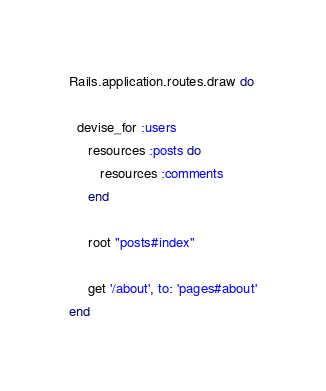Convert code to text. <code><loc_0><loc_0><loc_500><loc_500><_Ruby_>Rails.application.routes.draw do
	 
  devise_for :users
	 resources :posts do 
	 	resources :comments
	 end

	 root "posts#index"

	 get '/about', to: 'pages#about'
end
</code> 